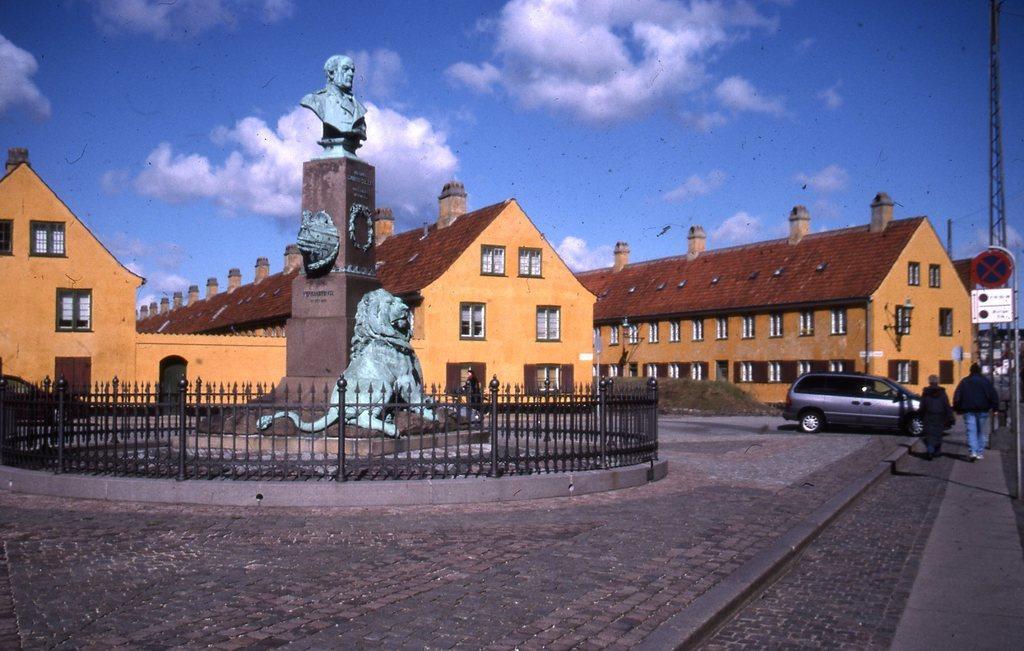Could you give a brief overview of what you see in this image? In this image we can see statues, fence, car on the road, two persons walking on the road, there is a sign board, few buildings, a pole and the sky with clouds. 